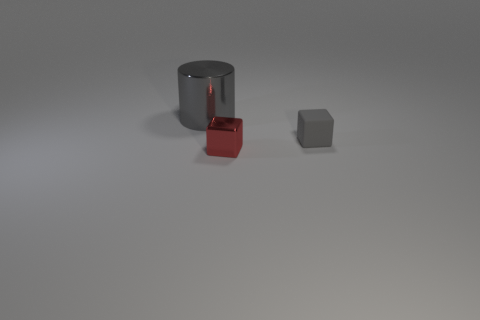Subtract all gray cubes. How many cubes are left? 1 Add 3 tiny red metallic cubes. How many objects exist? 6 Subtract 1 blocks. How many blocks are left? 1 Subtract all yellow cylinders. Subtract all purple spheres. How many cylinders are left? 1 Add 3 tiny red metallic cubes. How many tiny red metallic cubes are left? 4 Add 2 large metal things. How many large metal things exist? 3 Subtract 0 blue balls. How many objects are left? 3 Subtract all cubes. How many objects are left? 1 Subtract all blue balls. How many green cylinders are left? 0 Subtract all large matte blocks. Subtract all tiny red things. How many objects are left? 2 